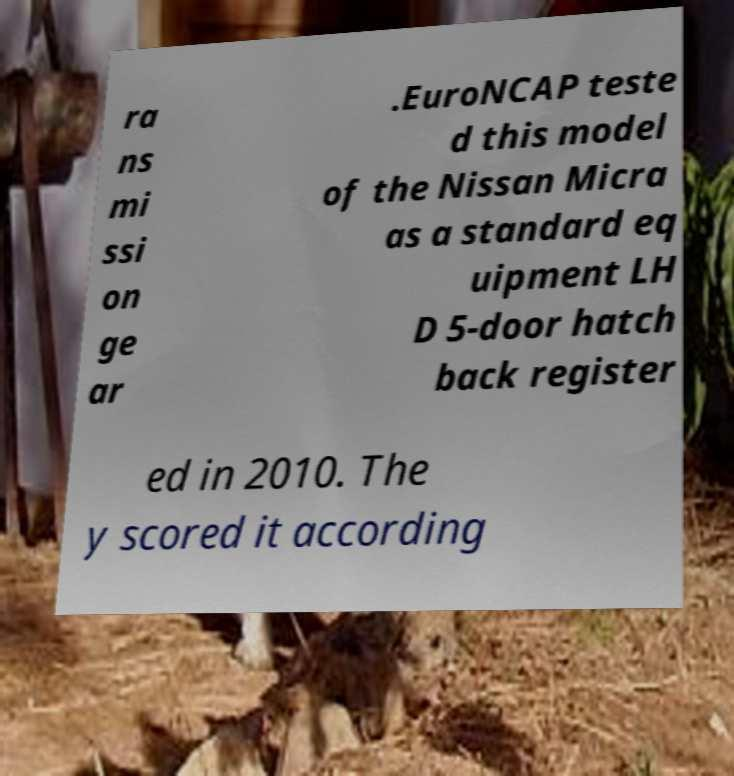What messages or text are displayed in this image? I need them in a readable, typed format. ra ns mi ssi on ge ar .EuroNCAP teste d this model of the Nissan Micra as a standard eq uipment LH D 5-door hatch back register ed in 2010. The y scored it according 